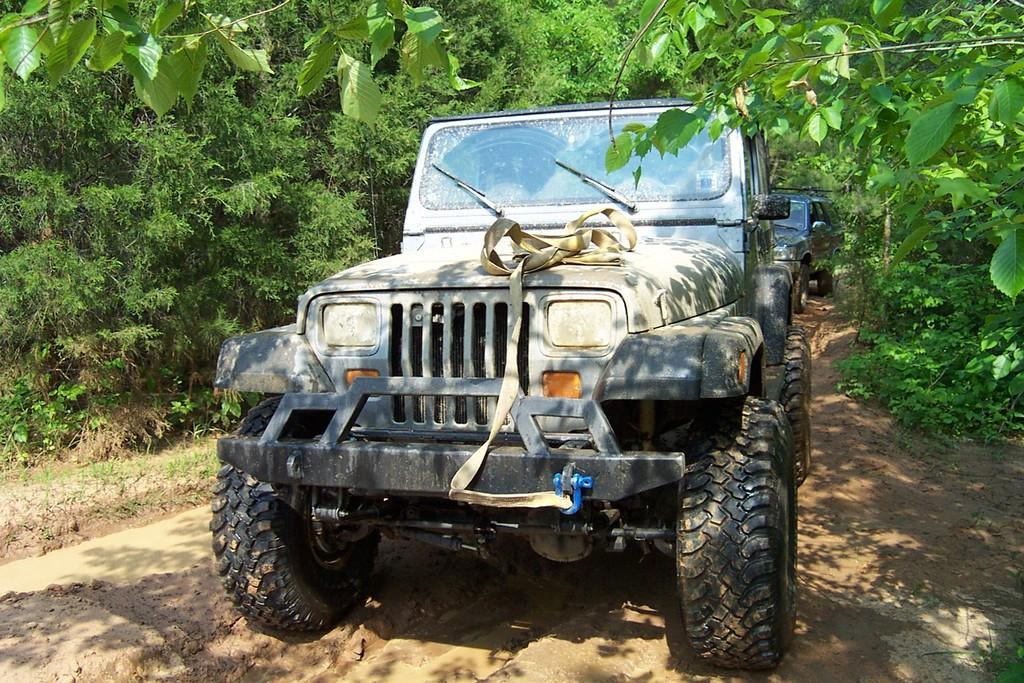What types of vehicles are in the image? The image contains vehicles, but the specific types cannot be determined from the provided facts. What is the terrain like in the image? The image features mud, which suggests a potentially wet or uneven surface. What type of vegetation is present in the image? There are trees and grass visible in the image. What type of shoes can be seen on the side of the image? There is no mention of shoes in the provided facts, so it cannot be determined if any shoes are present in the image. 